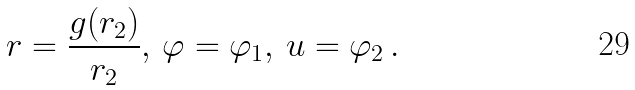Convert formula to latex. <formula><loc_0><loc_0><loc_500><loc_500>r = \frac { g ( r _ { 2 } ) } { r _ { 2 } } , \, \varphi = \varphi _ { 1 } , \, u = \varphi _ { 2 } \, .</formula> 